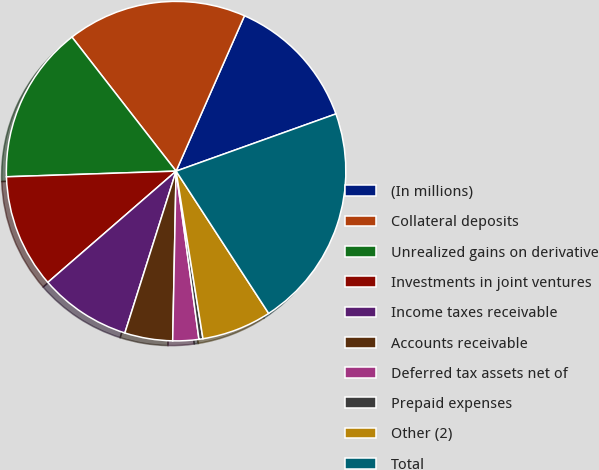Convert chart to OTSL. <chart><loc_0><loc_0><loc_500><loc_500><pie_chart><fcel>(In millions)<fcel>Collateral deposits<fcel>Unrealized gains on derivative<fcel>Investments in joint ventures<fcel>Income taxes receivable<fcel>Accounts receivable<fcel>Deferred tax assets net of<fcel>Prepaid expenses<fcel>Other (2)<fcel>Total<nl><fcel>12.93%<fcel>17.11%<fcel>15.02%<fcel>10.84%<fcel>8.75%<fcel>4.56%<fcel>2.47%<fcel>0.38%<fcel>6.65%<fcel>21.29%<nl></chart> 